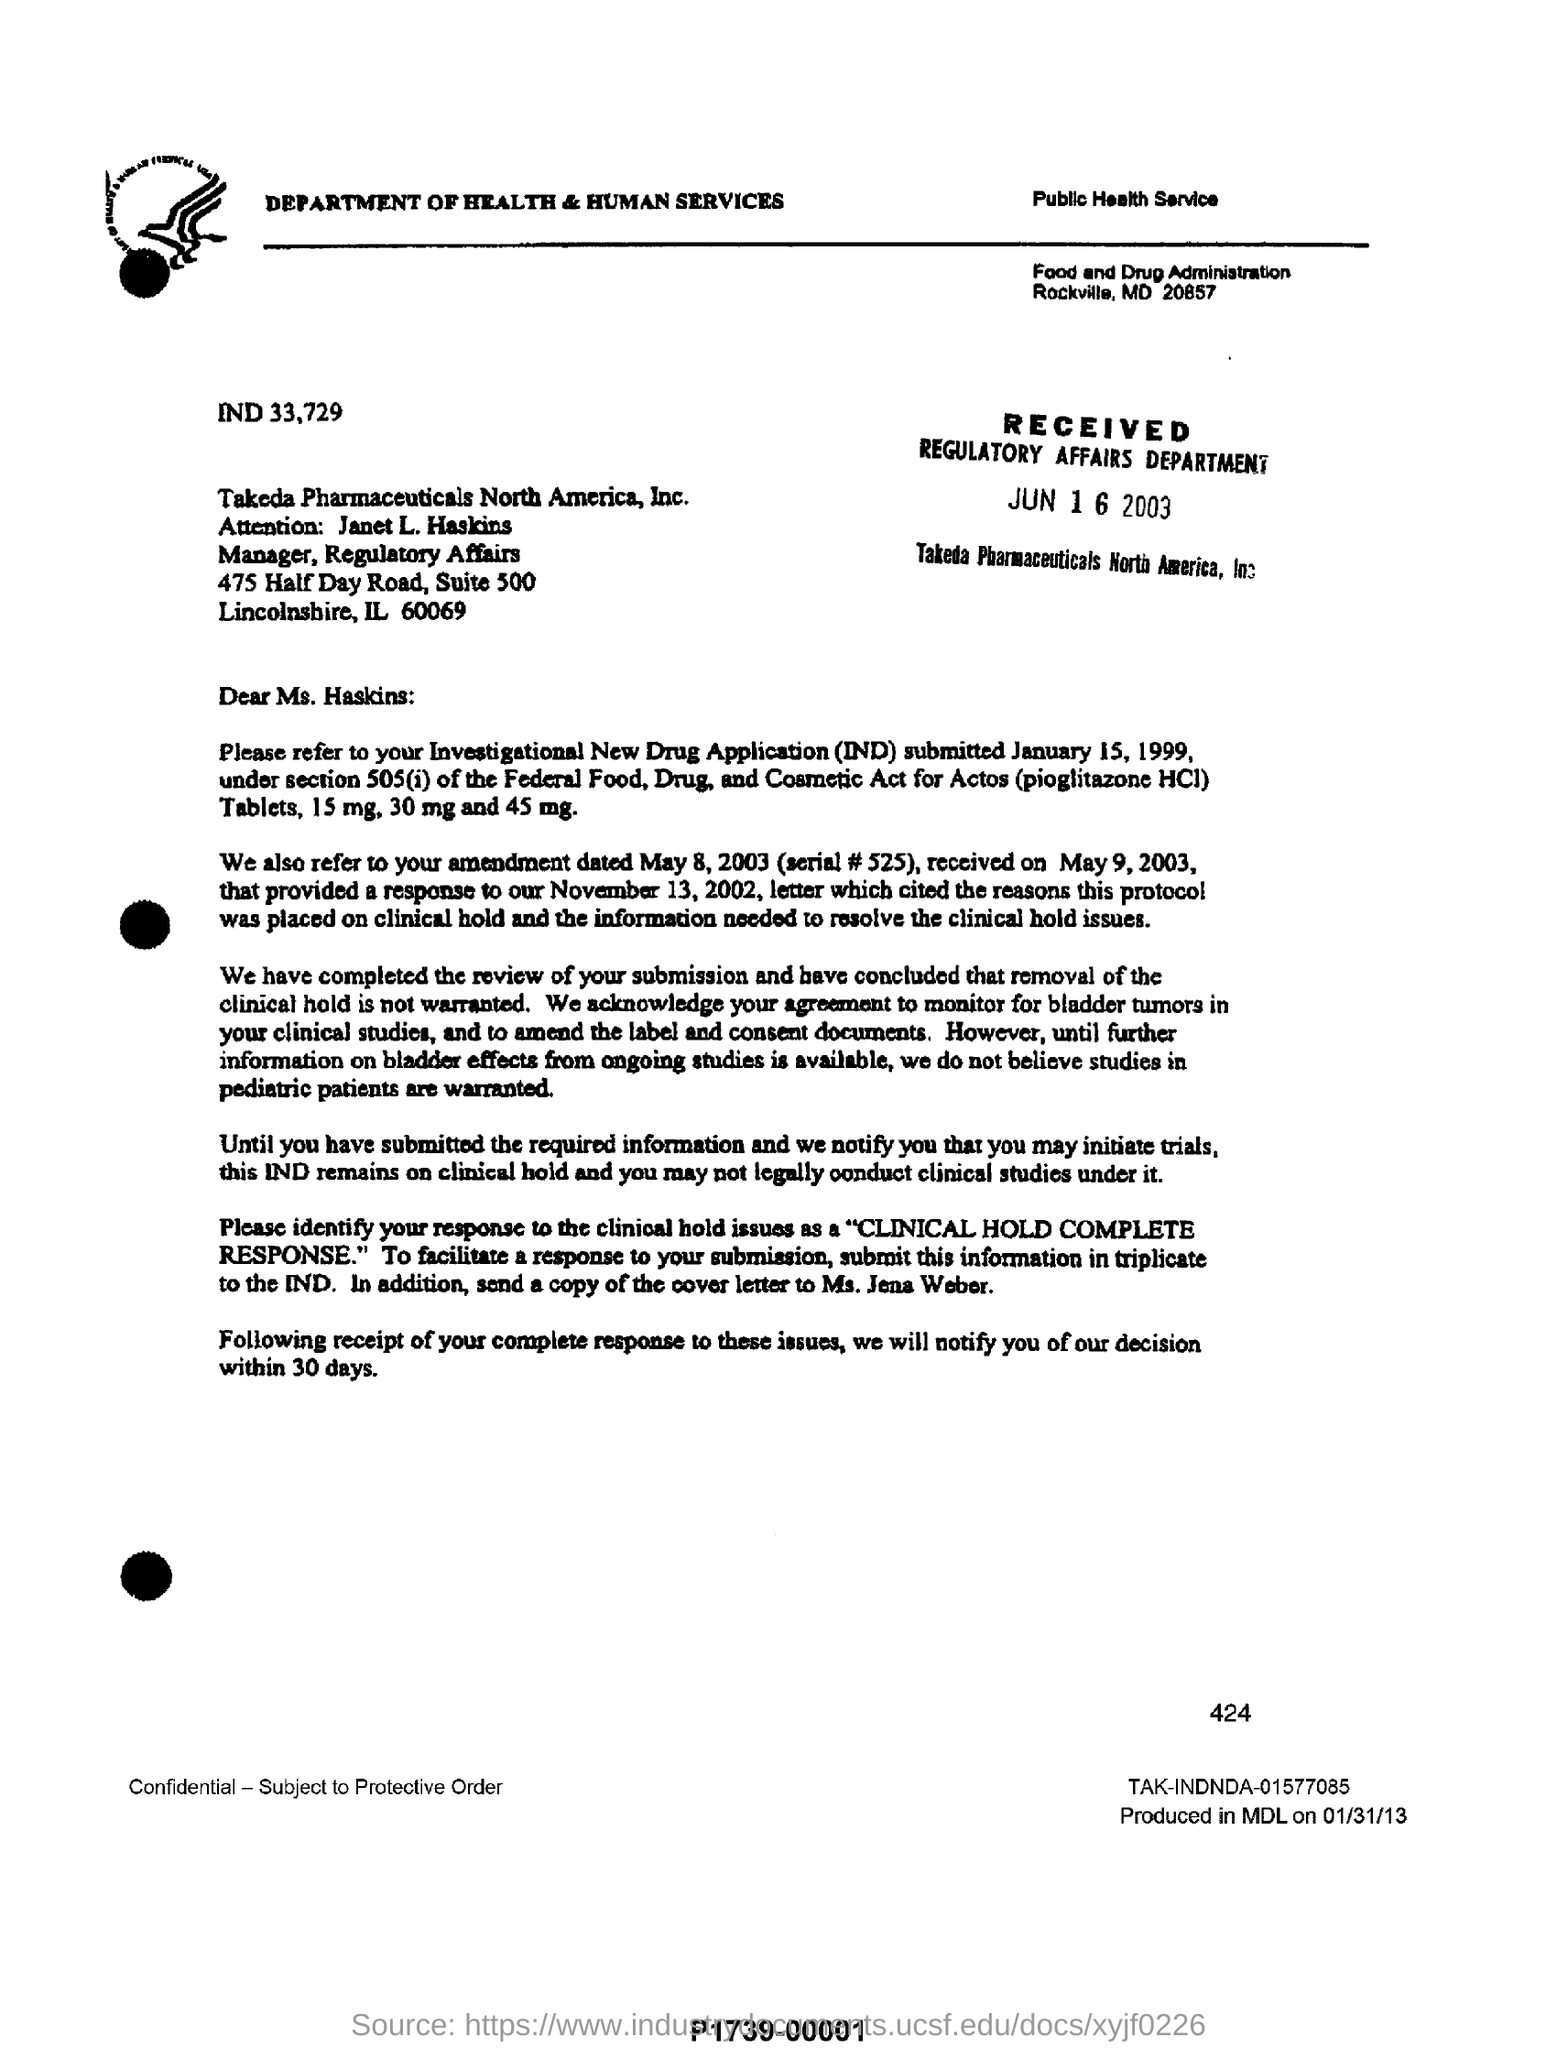What is the name of pharmaceuticals ?
Give a very brief answer. TAkeda pharmaceuticals North America ,INc. To whom this letter is written ?
Ensure brevity in your answer.  Ms. Haskins. When did Regulatory affairs department receive this letter?
Keep it short and to the point. JUN 16 2003. To whom a copy of cover letter has to be sent ?
Offer a terse response. Ms. Jens Weber. 